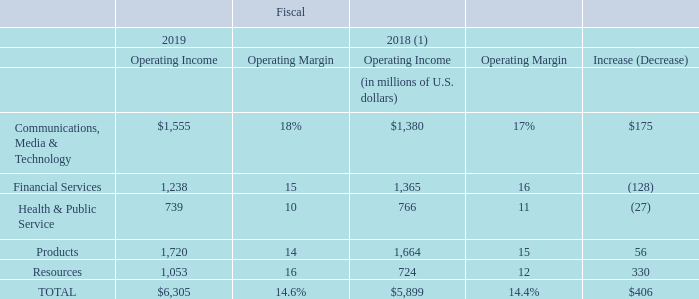Operating Income and Operating Margin
Operating income for fiscal 2019 increased $406 million, or 7%, over fiscal 2018.
Operating income and operating margin for each of the operating groups were as follows:
Amounts in table may not total due to rounding.
(1) Effective September 1, 2018, we adopted FASB ASU No. 2017-07, Compensation-Retirement Benefits (Topic 715): Improving the Presentation of Net Periodic Pension Cost and Net Periodic Postretirement Benefit Cost. Certain components of pension service costs were reclassified from Operating expenses to Non-operating expenses. Prior period amounts have been revised to conform with the current period presentation.
What is the change in total operating income between 2018 and 2019?
Answer scale should be: million. $406. What is the operating margin for health and public service in 2019?
Answer scale should be: percent. 10. What is the company's operating income in 2019?
Answer scale should be: million. $6,305. What is the company's main source of operating income in 2019? $1,720 is the highest operating income gained from any operating group in 2019
Answer: products. How much did total operating income gain from 2018 to 2019?
Answer scale should be: percent. 406/5,899
Answer: 6.88. What is the total operating margin from financial services and products in 2019?
Answer scale should be: percent. 15% + 14% 
Answer: 29. 